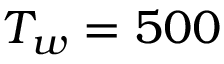<formula> <loc_0><loc_0><loc_500><loc_500>T _ { w } = 5 0 0</formula> 